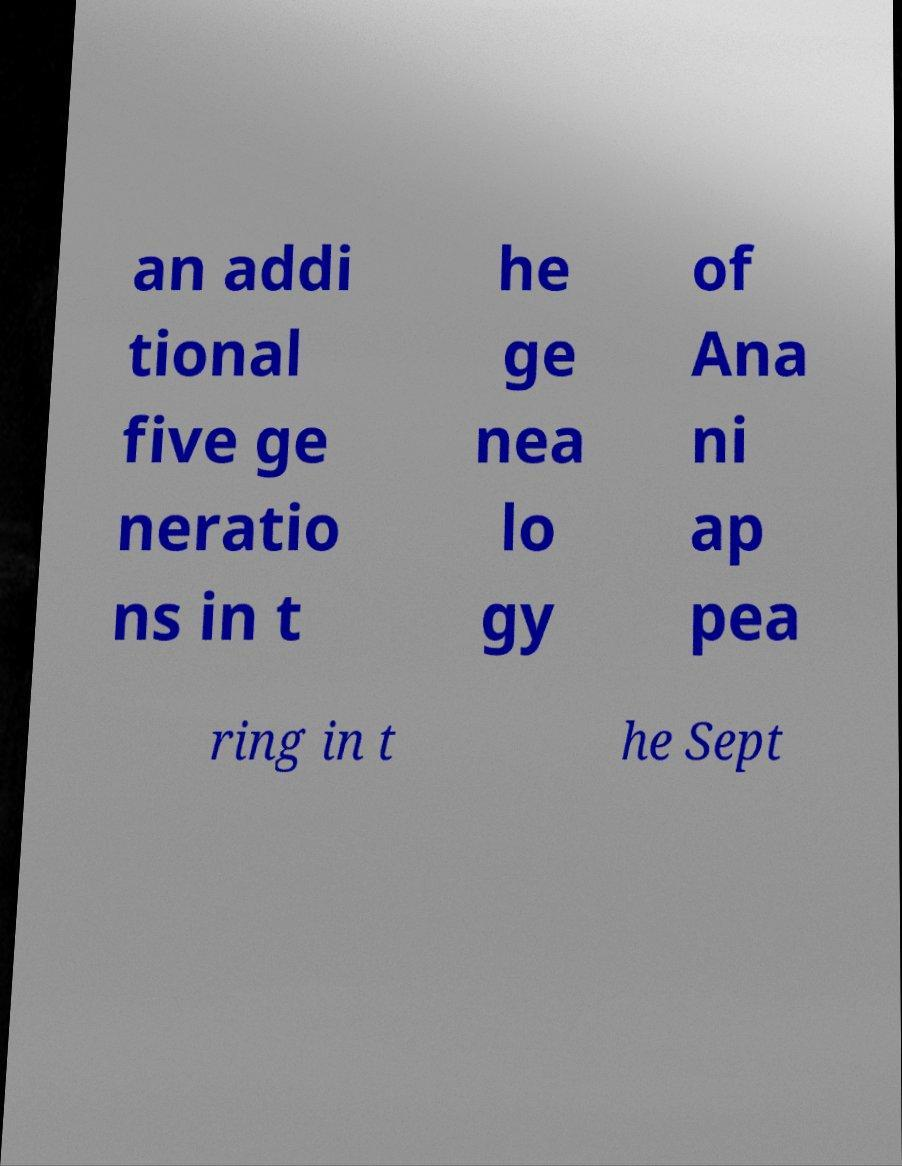For documentation purposes, I need the text within this image transcribed. Could you provide that? an addi tional five ge neratio ns in t he ge nea lo gy of Ana ni ap pea ring in t he Sept 